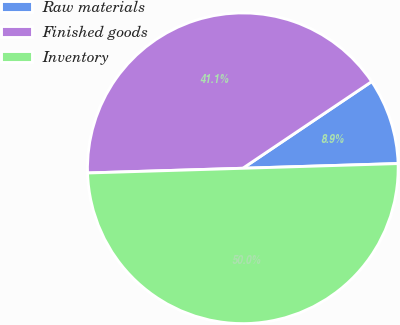Convert chart to OTSL. <chart><loc_0><loc_0><loc_500><loc_500><pie_chart><fcel>Raw materials<fcel>Finished goods<fcel>Inventory<nl><fcel>8.94%<fcel>41.06%<fcel>50.0%<nl></chart> 